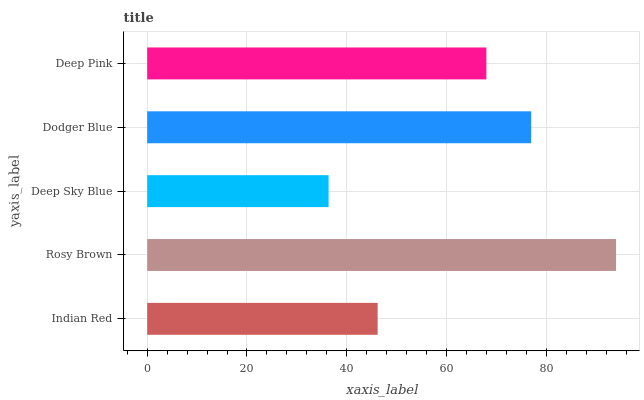Is Deep Sky Blue the minimum?
Answer yes or no. Yes. Is Rosy Brown the maximum?
Answer yes or no. Yes. Is Rosy Brown the minimum?
Answer yes or no. No. Is Deep Sky Blue the maximum?
Answer yes or no. No. Is Rosy Brown greater than Deep Sky Blue?
Answer yes or no. Yes. Is Deep Sky Blue less than Rosy Brown?
Answer yes or no. Yes. Is Deep Sky Blue greater than Rosy Brown?
Answer yes or no. No. Is Rosy Brown less than Deep Sky Blue?
Answer yes or no. No. Is Deep Pink the high median?
Answer yes or no. Yes. Is Deep Pink the low median?
Answer yes or no. Yes. Is Dodger Blue the high median?
Answer yes or no. No. Is Rosy Brown the low median?
Answer yes or no. No. 